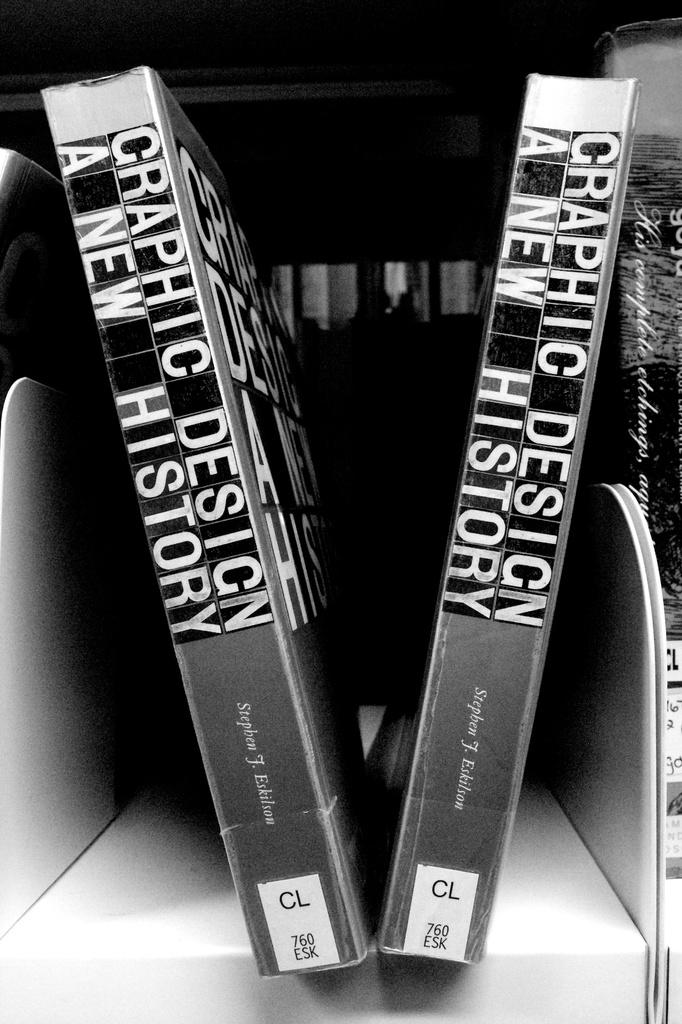<image>
Relay a brief, clear account of the picture shown. a book with the words 'graphic design a new history' on the spine of it 